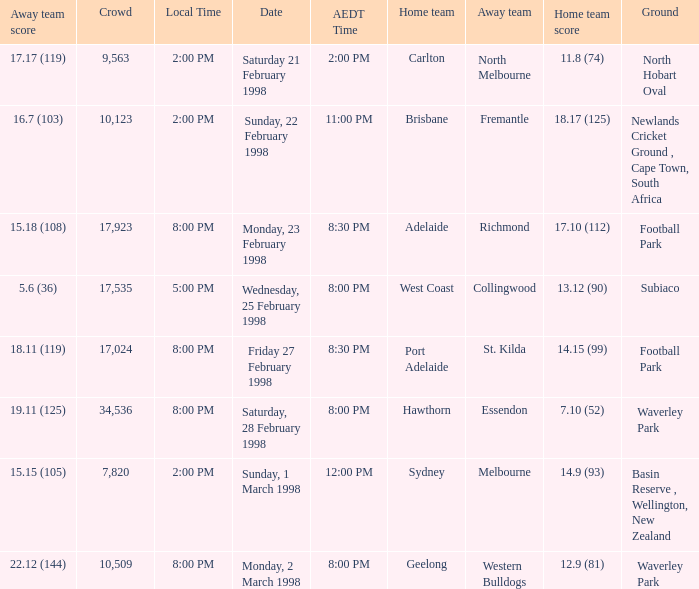Name the AEDT Time which has a Local Time of 8:00 pm, and a Away team score of 22.12 (144)? 8:00 PM. 